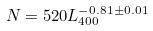Convert formula to latex. <formula><loc_0><loc_0><loc_500><loc_500>N = 5 2 0 L _ { 4 0 0 } ^ { - 0 . 8 1 \pm 0 . 0 1 }</formula> 